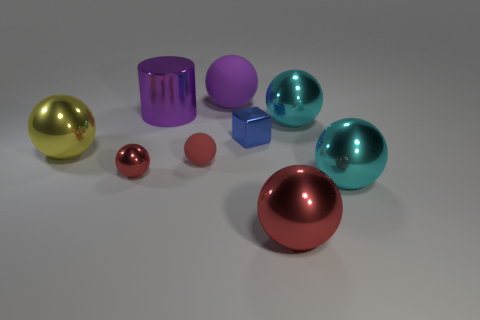There is a matte ball behind the tiny metal block; what is its size?
Provide a succinct answer. Large. How many cyan things are big metallic objects or metallic objects?
Ensure brevity in your answer.  2. Are there any cyan metal things that have the same size as the yellow shiny object?
Give a very brief answer. Yes. There is a purple sphere that is the same size as the metal cylinder; what material is it?
Make the answer very short. Rubber. There is a cyan thing in front of the yellow thing; is it the same size as the rubber thing on the left side of the large matte thing?
Make the answer very short. No. What number of objects are large yellow metallic cylinders or big shiny spheres on the left side of the blue metal object?
Offer a terse response. 1. Are there any other small metallic objects that have the same shape as the small blue thing?
Provide a succinct answer. No. There is a sphere that is to the right of the big cyan object that is behind the small matte ball; how big is it?
Your answer should be very brief. Large. Do the tiny shiny block and the tiny rubber sphere have the same color?
Provide a short and direct response. No. What number of matte things are small balls or purple objects?
Your answer should be very brief. 2. 